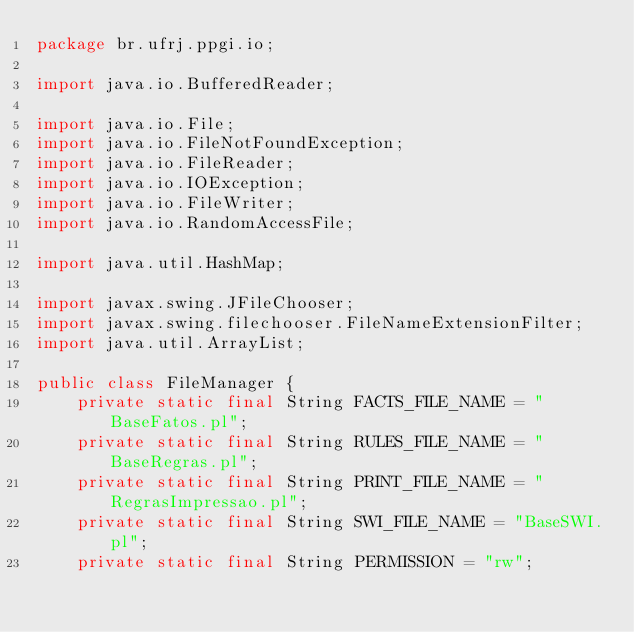<code> <loc_0><loc_0><loc_500><loc_500><_Java_>package br.ufrj.ppgi.io;

import java.io.BufferedReader;

import java.io.File;  
import java.io.FileNotFoundException;
import java.io.FileReader;
import java.io.IOException;
import java.io.FileWriter;
import java.io.RandomAccessFile;

import java.util.HashMap;

import javax.swing.JFileChooser;
import javax.swing.filechooser.FileNameExtensionFilter;
import java.util.ArrayList;

public class FileManager {
	private static final String FACTS_FILE_NAME = "BaseFatos.pl";
	private static final String RULES_FILE_NAME = "BaseRegras.pl";
	private static final String PRINT_FILE_NAME = "RegrasImpressao.pl";
	private static final String SWI_FILE_NAME = "BaseSWI.pl";
	private static final String PERMISSION = "rw";</code> 